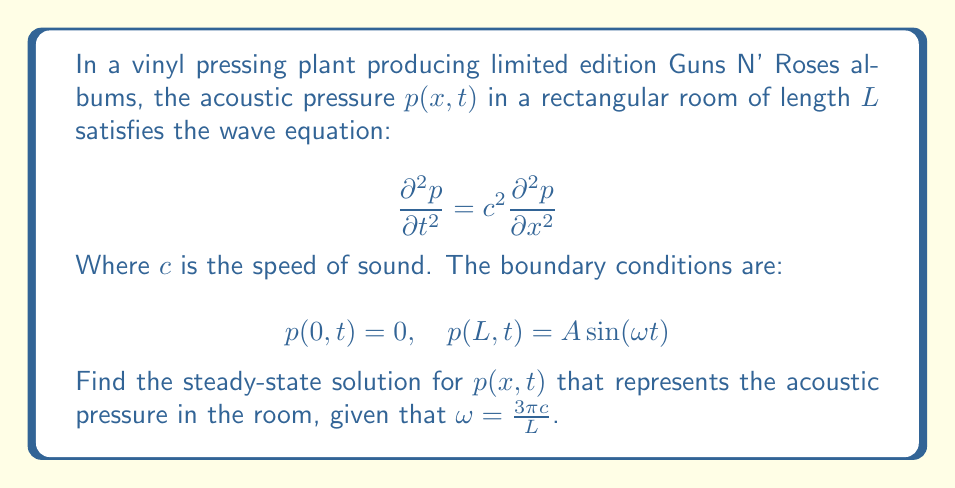Give your solution to this math problem. To solve this boundary value problem, we'll follow these steps:

1) The general solution for the steady-state wave equation is:

   $$p(x,t) = [C_1 \sin(kx) + C_2 \cos(kx)] \sin(\omega t)$$

   where $k = \frac{\omega}{c}$

2) Apply the first boundary condition $p(0,t) = 0$:

   $$0 = C_2 \sin(\omega t)$$

   This implies $C_2 = 0$

3) Our solution now becomes:

   $$p(x,t) = C_1 \sin(kx) \sin(\omega t)$$

4) Apply the second boundary condition $p(L,t) = A \sin(\omega t)$:

   $$A \sin(\omega t) = C_1 \sin(kL) \sin(\omega t)$$

   This implies $C_1 = \frac{A}{\sin(kL)}$

5) Substitute $\omega = \frac{3\pi c}{L}$ into $k = \frac{\omega}{c}$:

   $$k = \frac{3\pi}{L}$$

6) Now we can write our final solution:

   $$p(x,t) = \frac{A}{\sin(3\pi)} \sin\left(\frac{3\pi x}{L}\right) \sin\left(\frac{3\pi c t}{L}\right)$$

7) Simplify, noting that $\sin(3\pi) = 0$:

   $$p(x,t) = -A \sin\left(\frac{3\pi x}{L}\right) \sin\left(\frac{3\pi c t}{L}\right)$$

This solution represents a standing wave in the room, with three half-wavelengths fitting in the length of the room.
Answer: $$p(x,t) = -A \sin\left(\frac{3\pi x}{L}\right) \sin\left(\frac{3\pi c t}{L}\right)$$ 